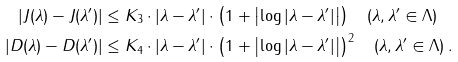Convert formula to latex. <formula><loc_0><loc_0><loc_500><loc_500>| J ( \lambda ) - J ( \lambda ^ { \prime } ) | & \leq K _ { 3 } \cdot | \lambda - \lambda ^ { \prime } | \cdot \left ( 1 + \left | \log | \lambda - \lambda ^ { \prime } | \right | \right ) \quad ( \lambda , \lambda ^ { \prime } \in \Lambda ) \\ | D ( \lambda ) - D ( \lambda ^ { \prime } ) | & \leq K _ { 4 } \cdot | \lambda - \lambda ^ { \prime } | \cdot \left ( 1 + \left | \log | \lambda - \lambda ^ { \prime } | \right | \right ) ^ { 2 } \quad ( \lambda , \lambda ^ { \prime } \in \Lambda ) \, .</formula> 